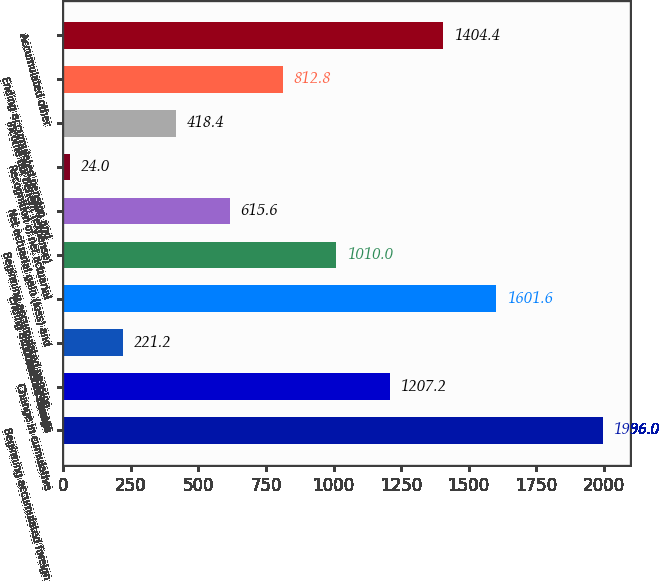Convert chart. <chart><loc_0><loc_0><loc_500><loc_500><bar_chart><fcel>Beginning accumulated foreign<fcel>Change in cumulative<fcel>Income tax benefit<fcel>Ending accumulated foreign<fcel>Beginning accumulated pension<fcel>Net actuarial gain (loss) and<fcel>Recognition of net actuarial<fcel>Income tax benefit (expense)<fcel>Ending accumulated pension and<fcel>Accumulated other<nl><fcel>1996<fcel>1207.2<fcel>221.2<fcel>1601.6<fcel>1010<fcel>615.6<fcel>24<fcel>418.4<fcel>812.8<fcel>1404.4<nl></chart> 